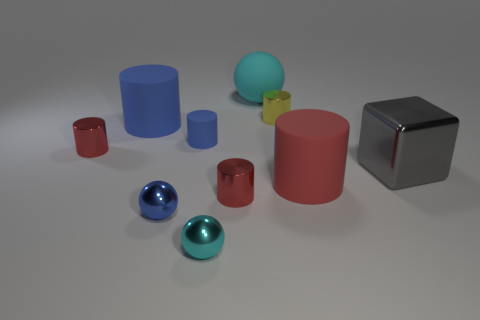Subtract all small red cylinders. How many cylinders are left? 4 Subtract all blue cylinders. How many cylinders are left? 4 Subtract all cylinders. How many objects are left? 4 Subtract 1 spheres. How many spheres are left? 2 Subtract all red cubes. Subtract all yellow cylinders. How many cubes are left? 1 Subtract 0 green cylinders. How many objects are left? 10 Subtract all purple cubes. How many yellow cylinders are left? 1 Subtract all big blue things. Subtract all big gray shiny cubes. How many objects are left? 8 Add 6 large gray cubes. How many large gray cubes are left? 7 Add 2 tiny red cylinders. How many tiny red cylinders exist? 4 